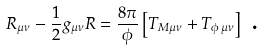<formula> <loc_0><loc_0><loc_500><loc_500>R _ { \mu \nu } - \frac { 1 } { 2 } g _ { \mu \nu } R = \frac { 8 \pi } \phi \left [ T _ { M \mu \nu } + T _ { \phi \, \mu \nu } \right ] \text { .}</formula> 